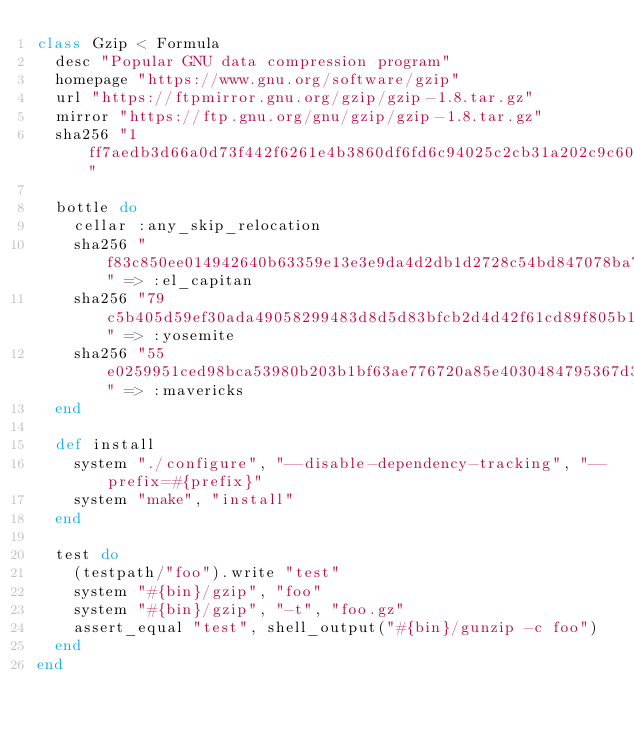Convert code to text. <code><loc_0><loc_0><loc_500><loc_500><_Ruby_>class Gzip < Formula
  desc "Popular GNU data compression program"
  homepage "https://www.gnu.org/software/gzip"
  url "https://ftpmirror.gnu.org/gzip/gzip-1.8.tar.gz"
  mirror "https://ftp.gnu.org/gnu/gzip/gzip-1.8.tar.gz"
  sha256 "1ff7aedb3d66a0d73f442f6261e4b3860df6fd6c94025c2cb31a202c9c60fe0e"

  bottle do
    cellar :any_skip_relocation
    sha256 "f83c850ee014942640b63359e13e3e9da4d2db1d2728c54bd847078ba7817777" => :el_capitan
    sha256 "79c5b405d59ef30ada49058299483d8d5d83bfcb2d4d42f61cd89f805b1f4f2a" => :yosemite
    sha256 "55e0259951ced98bca53980b203b1bf63ae776720a85e4030484795367d3971d" => :mavericks
  end

  def install
    system "./configure", "--disable-dependency-tracking", "--prefix=#{prefix}"
    system "make", "install"
  end

  test do
    (testpath/"foo").write "test"
    system "#{bin}/gzip", "foo"
    system "#{bin}/gzip", "-t", "foo.gz"
    assert_equal "test", shell_output("#{bin}/gunzip -c foo")
  end
end
</code> 